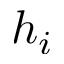Convert formula to latex. <formula><loc_0><loc_0><loc_500><loc_500>h _ { i }</formula> 